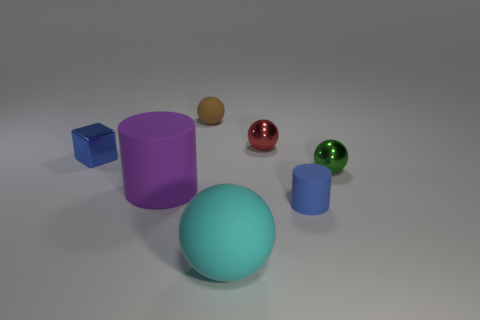There is a tiny cylinder that is made of the same material as the tiny brown sphere; what color is it?
Your response must be concise. Blue. Are there any red objects that have the same size as the metal block?
Provide a short and direct response. Yes. What number of objects are either rubber cylinders that are in front of the big cylinder or tiny things in front of the green metal object?
Provide a succinct answer. 1. There is a blue matte object that is the same size as the green metal sphere; what shape is it?
Provide a short and direct response. Cylinder. Are there any other large objects of the same shape as the large purple rubber thing?
Give a very brief answer. No. Is the number of tiny green objects less than the number of cyan metal cylinders?
Provide a succinct answer. No. Does the rubber ball to the left of the large cyan thing have the same size as the rubber cylinder to the left of the red metal ball?
Your answer should be very brief. No. How many things are small metallic spheres or small purple things?
Give a very brief answer. 2. What is the size of the rubber ball that is behind the large cyan matte object?
Offer a terse response. Small. What number of large things are behind the large rubber thing in front of the cylinder on the left side of the small red sphere?
Your response must be concise. 1. 